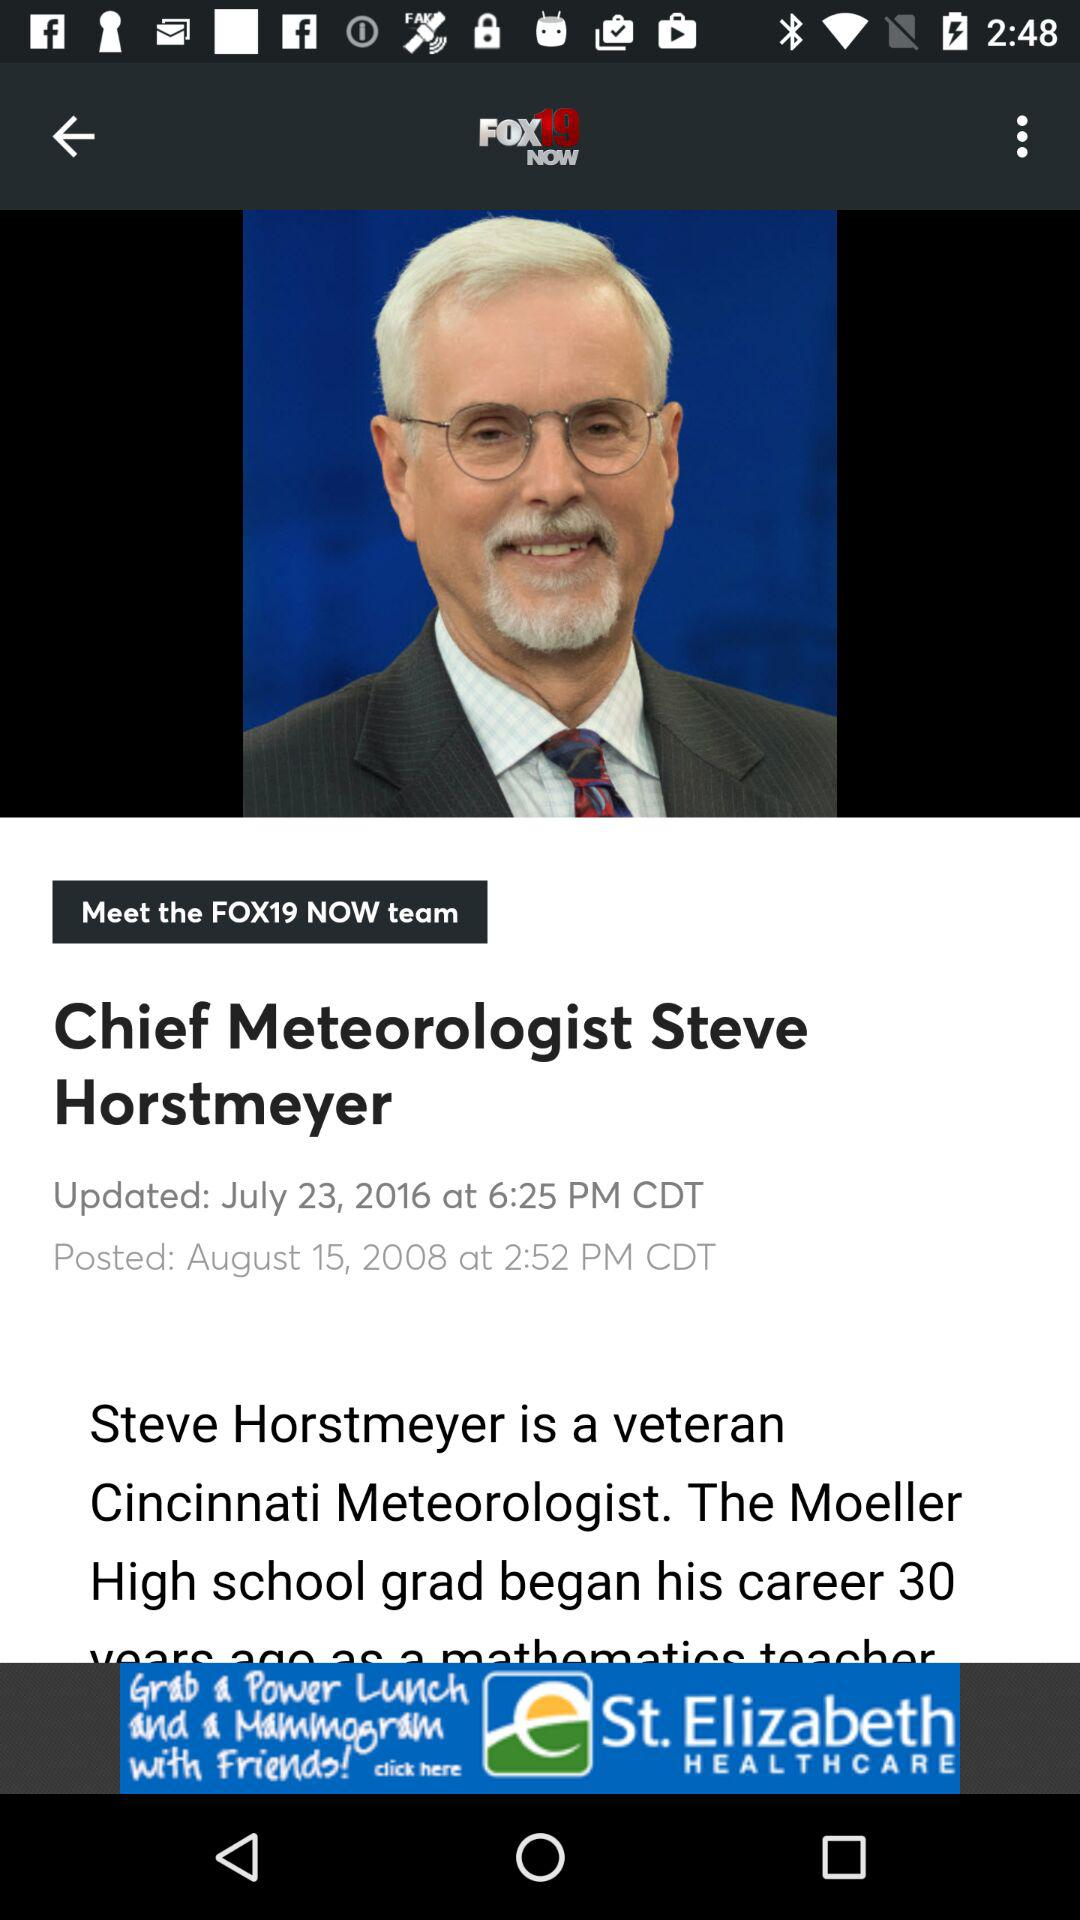What is the title of the article? The title of the article is "Chief Meteorologist Steve Horstmeyer". 